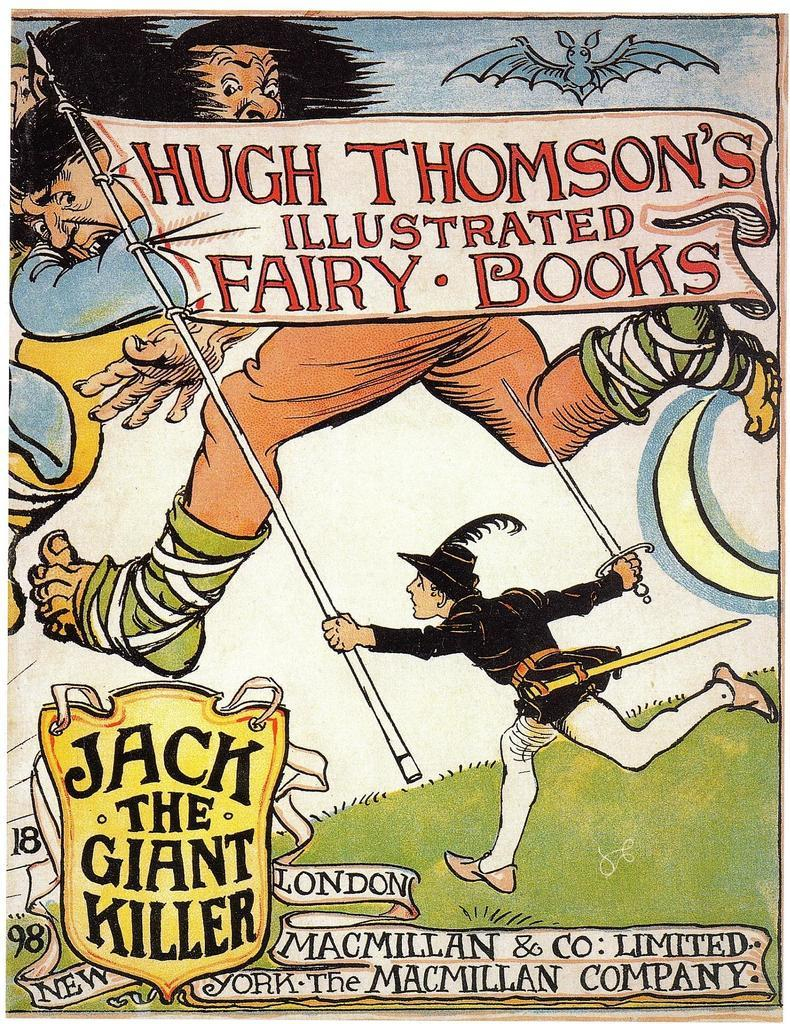<image>
Create a compact narrative representing the image presented. A fairy tale book about jack the giant killer. 